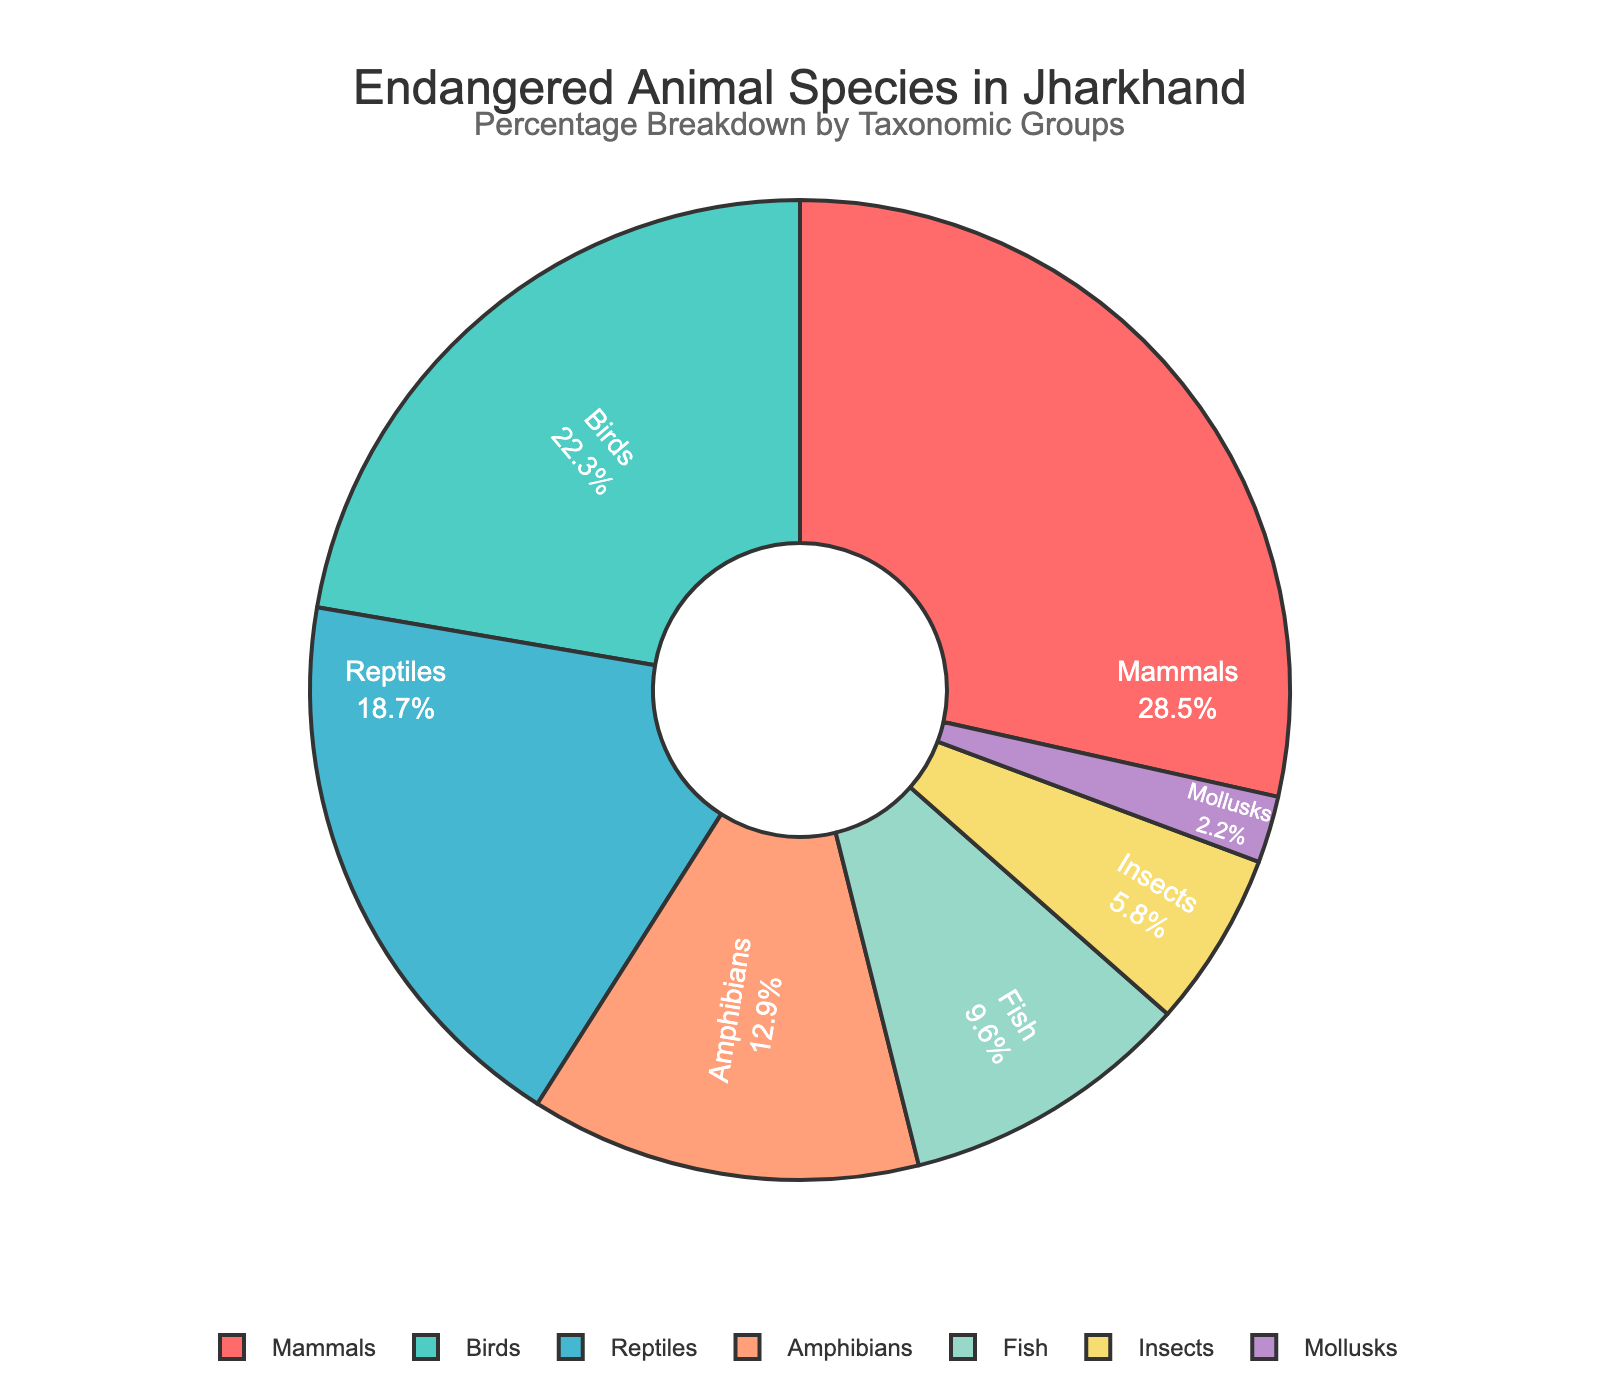What's the most prevalent taxonomic group among endangered species in Jharkhand? The pie chart shows the percentage breakdown of various taxonomic groups. The segment representing Mammals has the highest percentage.
Answer: Mammals Which taxonomic group has almost the same percentage of endangered species as reptiles? The pie chart shows that Birds have a percentage (22.3%) close to that of Reptiles (18.7%).
Answer: Birds What is the combined percentage of endangered Amphibians and Fish in Jharkhand? The pie chart lists the percentages of these groups as 12.9% for Amphibians and 9.6% for Fish. Adding these gives 12.9% + 9.6% = 22.5%.
Answer: 22.5% Which taxonomic group has the smallest percentage of endangered species? By examining the pie chart, the smallest segment corresponds to Mollusks, which have a percentage of 2.2%.
Answer: Mollusks What is the difference in percentage between the group with the highest and the group with the lowest number of endangered species? The highest percentage is for Mammals at 28.5% and the lowest is for Mollusks at 2.2%. The difference is 28.5% - 2.2% = 26.3%.
Answer: 26.3% How do the percentages of endangered Mammals and Birds compare? According to the pie chart, Mammals make up 28.5% while Birds make up 22.3% of the endangered species. Mammals have a higher percentage than Birds.
Answer: Mammals have a higher percentage What percentage of the total does the Insects group contribute to? The pie chart segment for Insects shows that they make up 5.8% of the endangered species.
Answer: 5.8% Sum the percentage of endangered Mammals, Birds, and Reptiles in Jharkhand. Adding the percentages for Mammals (28.5%), Birds (22.3%), and Reptiles (18.7%) gives us: 28.5% + 22.3% + 18.7% = 69.5%.
Answer: 69.5% Are there more endangered Amphibians or Fish in Jharkhand? The pie chart shows Amphibians at 12.9% and Fish at 9.6%. Amphibians have a higher percentage than Fish.
Answer: Amphibians 